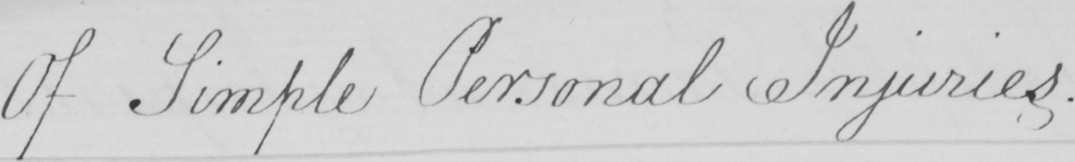Please transcribe the handwritten text in this image. Of Simple Personal Injuries. 